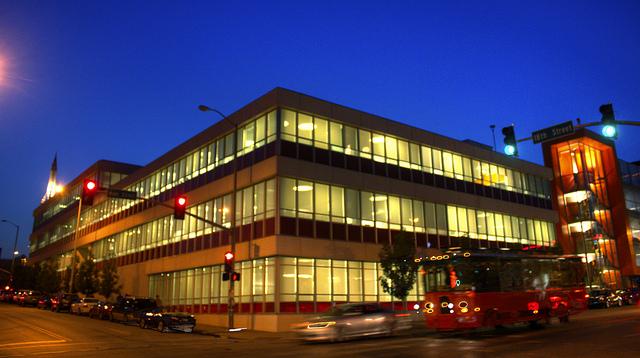Is it day time?
Answer briefly. No. What is in the center of the photo?
Quick response, please. Building. What shape is the top of the building in the background?
Short answer required. Square. Are any green traffic lights visible?
Short answer required. Yes. Are the lights on in this building?
Give a very brief answer. Yes. 